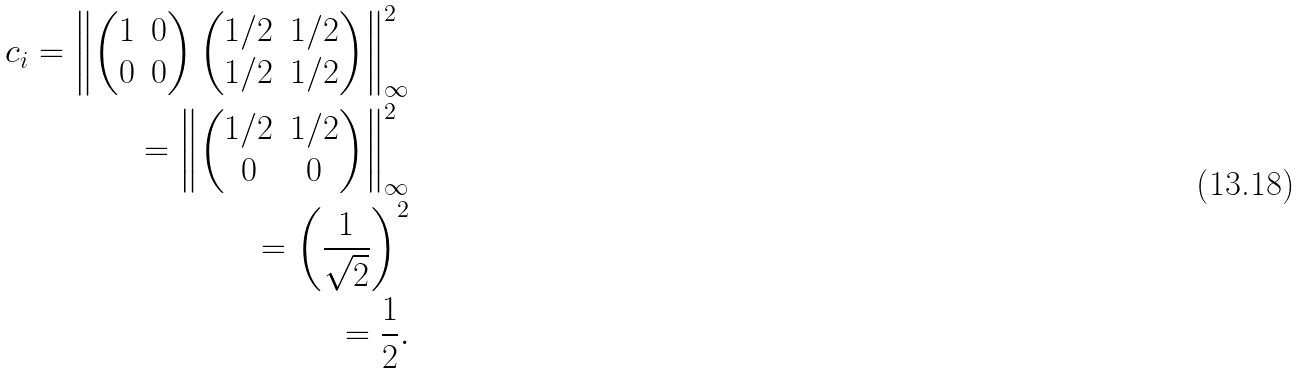Convert formula to latex. <formula><loc_0><loc_0><loc_500><loc_500>c _ { i } = \left \| \begin{pmatrix} 1 & 0 \\ 0 & 0 \end{pmatrix} \begin{pmatrix} 1 / 2 & 1 / 2 \\ 1 / 2 & 1 / 2 \end{pmatrix} \right \| _ { \infty } ^ { 2 } \\ = \left \| \begin{pmatrix} 1 / 2 & 1 / 2 \\ 0 & 0 \end{pmatrix} \right \| _ { \infty } ^ { 2 } \\ = \left ( \frac { 1 } { \sqrt { 2 } } \right ) ^ { 2 } \\ = \frac { 1 } { 2 } .</formula> 